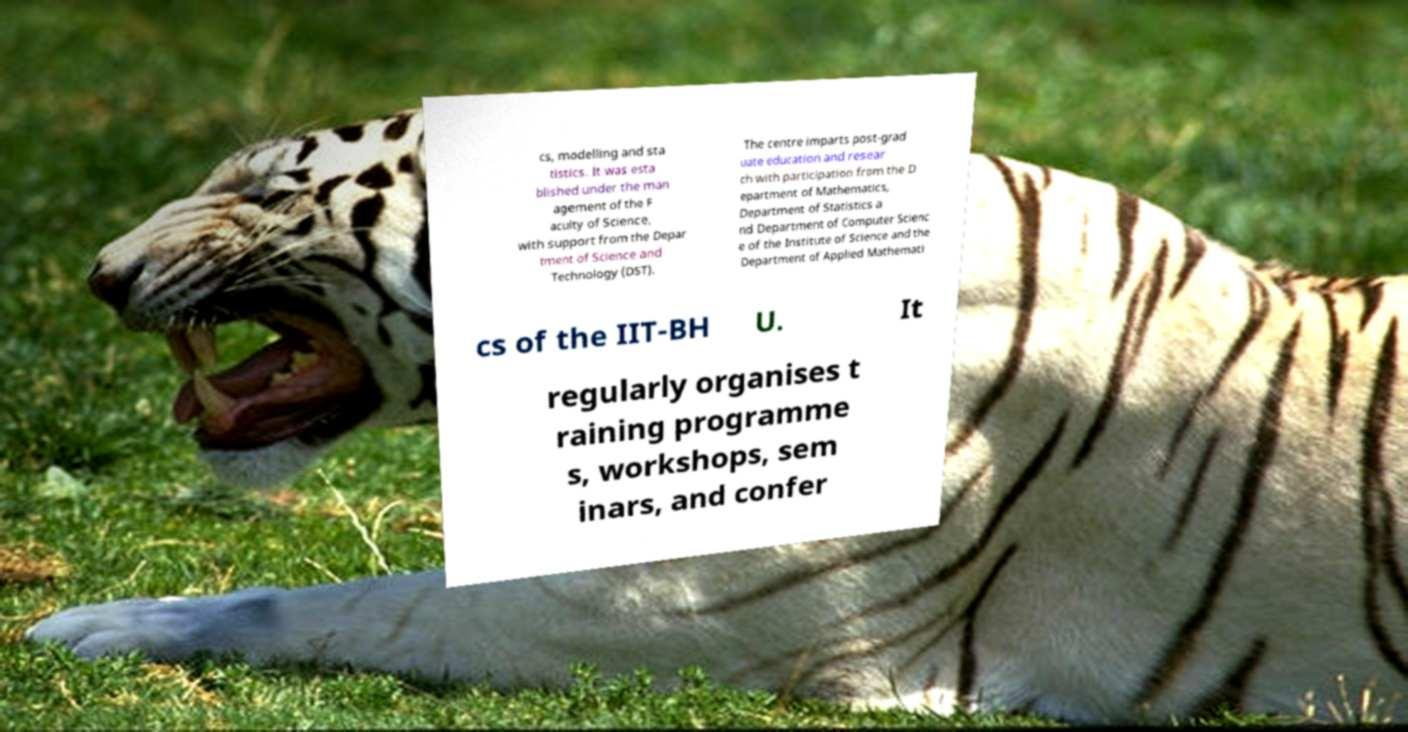For documentation purposes, I need the text within this image transcribed. Could you provide that? cs, modelling and sta tistics. It was esta blished under the man agement of the F aculty of Science, with support from the Depar tment of Science and Technology (DST). The centre imparts post-grad uate education and resear ch with participation from the D epartment of Mathematics, Department of Statistics a nd Department of Computer Scienc e of the Institute of Science and the Department of Applied Mathemati cs of the IIT-BH U. It regularly organises t raining programme s, workshops, sem inars, and confer 